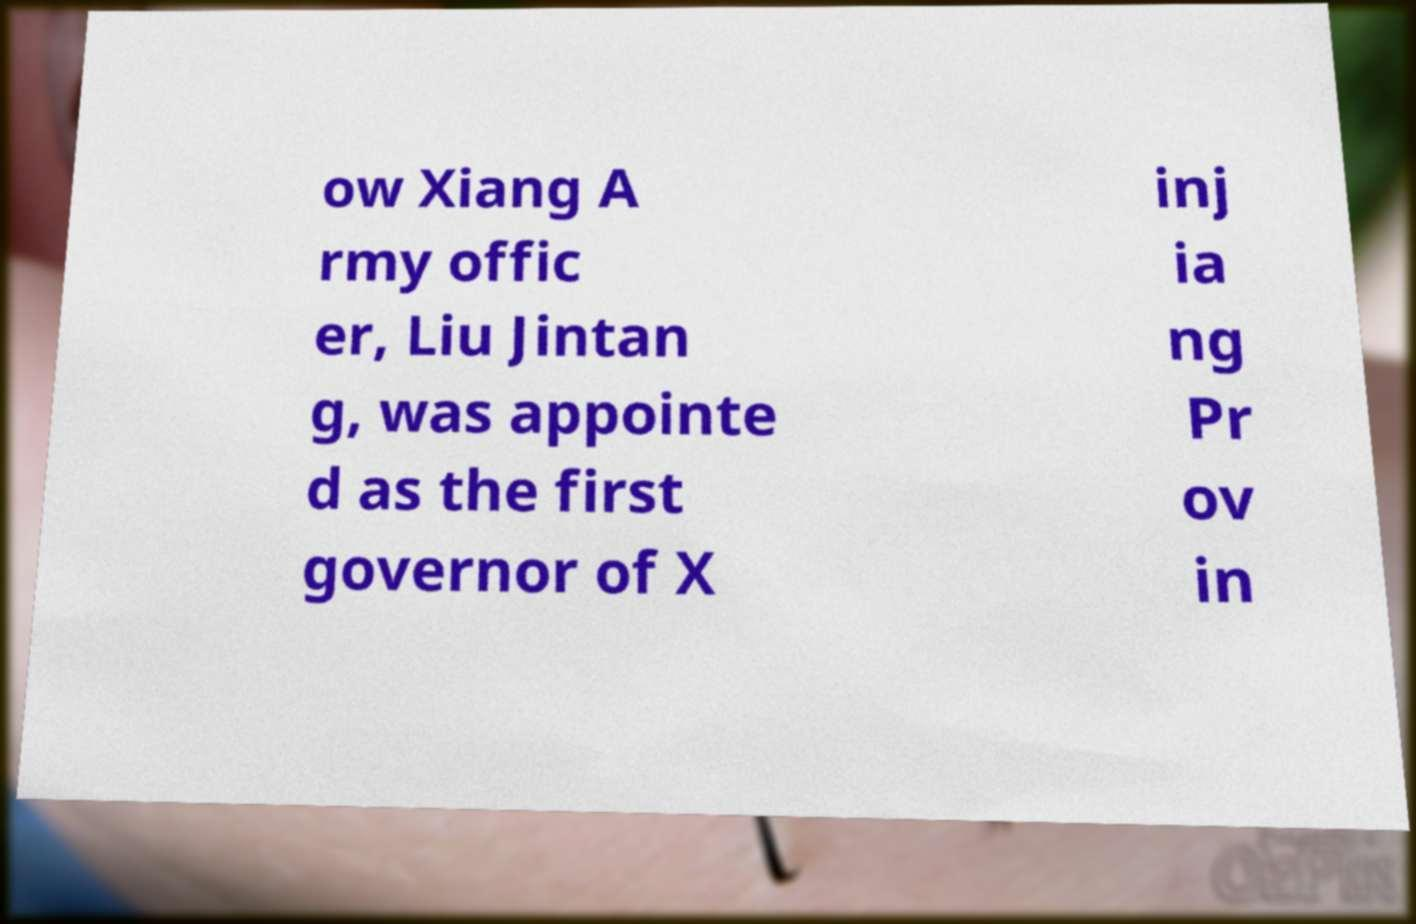There's text embedded in this image that I need extracted. Can you transcribe it verbatim? ow Xiang A rmy offic er, Liu Jintan g, was appointe d as the first governor of X inj ia ng Pr ov in 